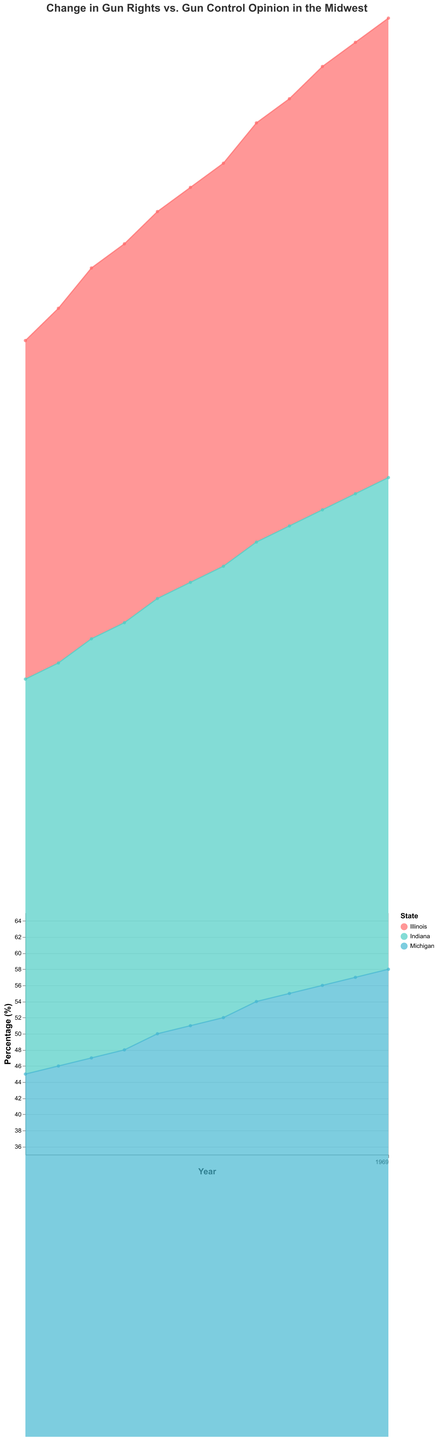How did the percentage of people in Illinois who support gun rights change from 2010 to 2021? From the figure, in 2010, the percentage of people in Illinois supporting gun rights was 42%, and in 2021 it was 57%. The change is 57% - 42% = 15%.
Answer: 15% Which state had the highest percentage of Pro-Gun Rights support in 2021? The figure shows the percentages for each state in 2021. Indiana had the highest at 61%.
Answer: Indiana How did the Pro-Gun Control opinion change in Michigan from 2010 to 2014? In 2010, the Pro-Gun Control opinion in Michigan was 55%, and in 2014 it was 50%. The change is 50% - 55% = -5%.
Answer: -5% What was the trend for Pro-Gun Rights opinions in Indiana from 2012 to 2020? The figure shows a steady increase from 52% in 2012 to 60% in 2020.
Answer: Steady increase Compare the 2010 Pro-Gun Rights percentages between Illinois and Indiana. Which state had a higher percentage? The figure shows that Illinois had 42% and Indiana had 49% in 2010. Indiana had a higher percentage.
Answer: Indiana What’s the average percentage of Pro-Gun Rights support for Michigan from 2010 to 2012? From the figure: 2010 (45%), 2011 (46%), 2012 (47%). The average is (45 + 46 + 47) / 3 = 46%.
Answer: 46% Did Pro-Gun Rights in any state surpass 60% between 2010 and 2021? The figure indicates that Indiana surpassed 60% in 2021, reaching 61%.
Answer: Yes, Indiana in 2021 For Illinois, during which year did Pro-Gun Rights equal Pro-Gun Control? In 2016, the figure shows both were at 50%.
Answer: 2016 Which state shows the most rapid increase in Pro-Gun Rights opinion from 2010 to 2021? From the figure, Indiana shows the most rapid increase from 49% in 2010 to 61% in 2021, a 12% increase.
Answer: Indiana In what year did Pro-Gun Rights support in Michigan equal the Pro-Gun Rights support in Illinois for the same year? The figure shows both Michigan and Illinois had 50% Pro-Gun Rights support in 2016.
Answer: 2016 